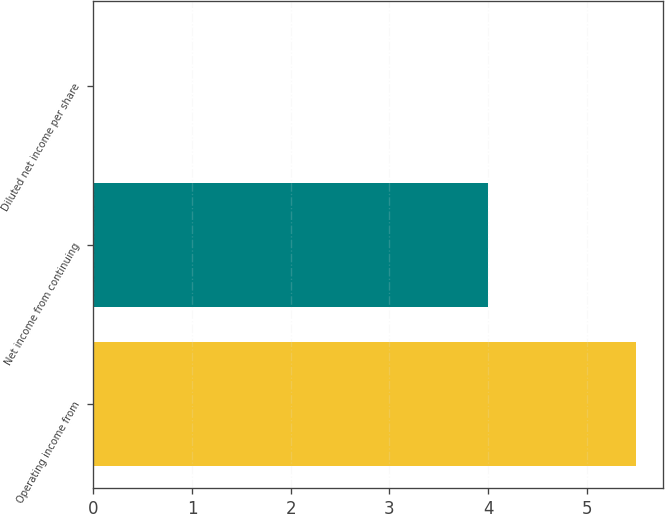<chart> <loc_0><loc_0><loc_500><loc_500><bar_chart><fcel>Operating income from<fcel>Net income from continuing<fcel>Diluted net income per share<nl><fcel>5.5<fcel>4<fcel>0.01<nl></chart> 